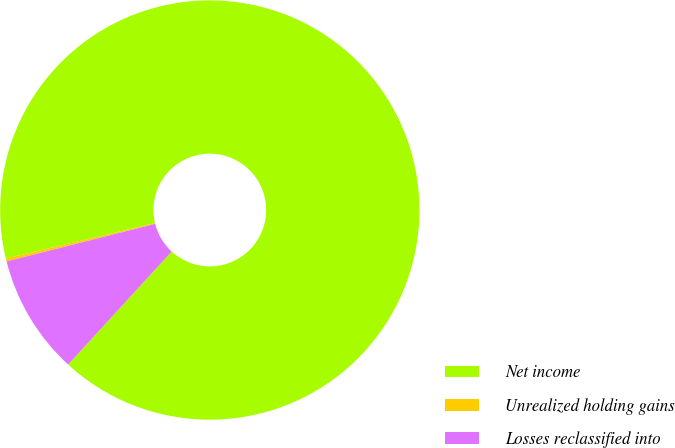Convert chart. <chart><loc_0><loc_0><loc_500><loc_500><pie_chart><fcel>Net income<fcel>Unrealized holding gains<fcel>Losses reclassified into<nl><fcel>90.53%<fcel>0.22%<fcel>9.25%<nl></chart> 